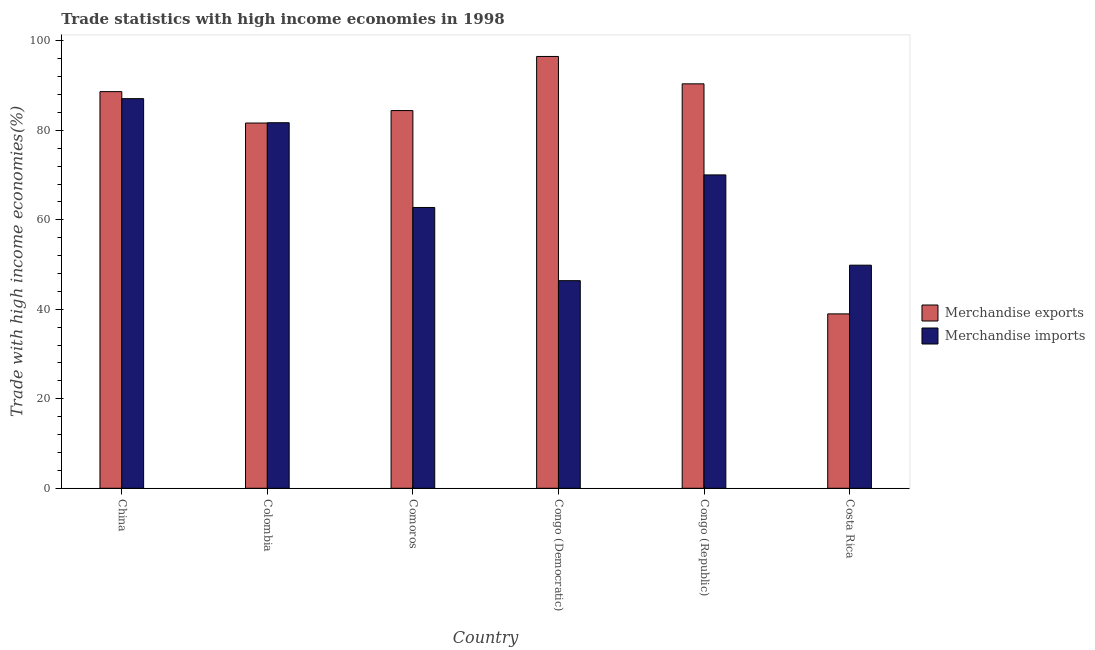How many groups of bars are there?
Ensure brevity in your answer.  6. Are the number of bars per tick equal to the number of legend labels?
Your answer should be compact. Yes. Are the number of bars on each tick of the X-axis equal?
Your response must be concise. Yes. How many bars are there on the 3rd tick from the left?
Your answer should be compact. 2. What is the label of the 5th group of bars from the left?
Give a very brief answer. Congo (Republic). What is the merchandise imports in Comoros?
Your answer should be very brief. 62.76. Across all countries, what is the maximum merchandise imports?
Keep it short and to the point. 87.08. Across all countries, what is the minimum merchandise imports?
Offer a terse response. 46.4. In which country was the merchandise exports minimum?
Offer a very short reply. Costa Rica. What is the total merchandise imports in the graph?
Offer a terse response. 397.84. What is the difference between the merchandise imports in Colombia and that in Congo (Republic)?
Your answer should be very brief. 11.66. What is the difference between the merchandise exports in Congo (Democratic) and the merchandise imports in Colombia?
Provide a succinct answer. 14.81. What is the average merchandise imports per country?
Provide a succinct answer. 66.31. What is the difference between the merchandise exports and merchandise imports in Colombia?
Your response must be concise. -0.07. What is the ratio of the merchandise exports in Colombia to that in Comoros?
Make the answer very short. 0.97. Is the difference between the merchandise imports in Colombia and Congo (Democratic) greater than the difference between the merchandise exports in Colombia and Congo (Democratic)?
Provide a short and direct response. Yes. What is the difference between the highest and the second highest merchandise exports?
Give a very brief answer. 6.12. What is the difference between the highest and the lowest merchandise exports?
Provide a short and direct response. 57.53. Is the sum of the merchandise exports in China and Congo (Democratic) greater than the maximum merchandise imports across all countries?
Provide a succinct answer. Yes. What does the 2nd bar from the right in China represents?
Your response must be concise. Merchandise exports. How many bars are there?
Offer a very short reply. 12. Are all the bars in the graph horizontal?
Provide a succinct answer. No. How many countries are there in the graph?
Provide a short and direct response. 6. What is the difference between two consecutive major ticks on the Y-axis?
Keep it short and to the point. 20. Does the graph contain any zero values?
Offer a terse response. No. Where does the legend appear in the graph?
Provide a succinct answer. Center right. How are the legend labels stacked?
Offer a very short reply. Vertical. What is the title of the graph?
Offer a very short reply. Trade statistics with high income economies in 1998. What is the label or title of the Y-axis?
Your answer should be very brief. Trade with high income economies(%). What is the Trade with high income economies(%) of Merchandise exports in China?
Give a very brief answer. 88.65. What is the Trade with high income economies(%) in Merchandise imports in China?
Give a very brief answer. 87.08. What is the Trade with high income economies(%) in Merchandise exports in Colombia?
Make the answer very short. 81.63. What is the Trade with high income economies(%) of Merchandise imports in Colombia?
Your response must be concise. 81.7. What is the Trade with high income economies(%) of Merchandise exports in Comoros?
Keep it short and to the point. 84.42. What is the Trade with high income economies(%) in Merchandise imports in Comoros?
Make the answer very short. 62.76. What is the Trade with high income economies(%) of Merchandise exports in Congo (Democratic)?
Provide a short and direct response. 96.51. What is the Trade with high income economies(%) in Merchandise imports in Congo (Democratic)?
Offer a very short reply. 46.4. What is the Trade with high income economies(%) in Merchandise exports in Congo (Republic)?
Offer a terse response. 90.39. What is the Trade with high income economies(%) in Merchandise imports in Congo (Republic)?
Your answer should be very brief. 70.04. What is the Trade with high income economies(%) in Merchandise exports in Costa Rica?
Give a very brief answer. 38.98. What is the Trade with high income economies(%) of Merchandise imports in Costa Rica?
Give a very brief answer. 49.86. Across all countries, what is the maximum Trade with high income economies(%) in Merchandise exports?
Your answer should be compact. 96.51. Across all countries, what is the maximum Trade with high income economies(%) in Merchandise imports?
Give a very brief answer. 87.08. Across all countries, what is the minimum Trade with high income economies(%) in Merchandise exports?
Make the answer very short. 38.98. Across all countries, what is the minimum Trade with high income economies(%) in Merchandise imports?
Your answer should be very brief. 46.4. What is the total Trade with high income economies(%) in Merchandise exports in the graph?
Your response must be concise. 480.57. What is the total Trade with high income economies(%) of Merchandise imports in the graph?
Ensure brevity in your answer.  397.84. What is the difference between the Trade with high income economies(%) in Merchandise exports in China and that in Colombia?
Your answer should be compact. 7.02. What is the difference between the Trade with high income economies(%) in Merchandise imports in China and that in Colombia?
Give a very brief answer. 5.38. What is the difference between the Trade with high income economies(%) in Merchandise exports in China and that in Comoros?
Make the answer very short. 4.23. What is the difference between the Trade with high income economies(%) of Merchandise imports in China and that in Comoros?
Your response must be concise. 24.32. What is the difference between the Trade with high income economies(%) of Merchandise exports in China and that in Congo (Democratic)?
Provide a short and direct response. -7.86. What is the difference between the Trade with high income economies(%) in Merchandise imports in China and that in Congo (Democratic)?
Your answer should be very brief. 40.68. What is the difference between the Trade with high income economies(%) in Merchandise exports in China and that in Congo (Republic)?
Provide a short and direct response. -1.74. What is the difference between the Trade with high income economies(%) of Merchandise imports in China and that in Congo (Republic)?
Keep it short and to the point. 17.04. What is the difference between the Trade with high income economies(%) of Merchandise exports in China and that in Costa Rica?
Make the answer very short. 49.67. What is the difference between the Trade with high income economies(%) in Merchandise imports in China and that in Costa Rica?
Your response must be concise. 37.22. What is the difference between the Trade with high income economies(%) of Merchandise exports in Colombia and that in Comoros?
Give a very brief answer. -2.79. What is the difference between the Trade with high income economies(%) of Merchandise imports in Colombia and that in Comoros?
Your answer should be very brief. 18.94. What is the difference between the Trade with high income economies(%) in Merchandise exports in Colombia and that in Congo (Democratic)?
Your response must be concise. -14.88. What is the difference between the Trade with high income economies(%) in Merchandise imports in Colombia and that in Congo (Democratic)?
Provide a succinct answer. 35.3. What is the difference between the Trade with high income economies(%) of Merchandise exports in Colombia and that in Congo (Republic)?
Keep it short and to the point. -8.76. What is the difference between the Trade with high income economies(%) of Merchandise imports in Colombia and that in Congo (Republic)?
Keep it short and to the point. 11.66. What is the difference between the Trade with high income economies(%) in Merchandise exports in Colombia and that in Costa Rica?
Keep it short and to the point. 42.65. What is the difference between the Trade with high income economies(%) in Merchandise imports in Colombia and that in Costa Rica?
Ensure brevity in your answer.  31.84. What is the difference between the Trade with high income economies(%) of Merchandise exports in Comoros and that in Congo (Democratic)?
Provide a short and direct response. -12.09. What is the difference between the Trade with high income economies(%) in Merchandise imports in Comoros and that in Congo (Democratic)?
Your answer should be very brief. 16.36. What is the difference between the Trade with high income economies(%) in Merchandise exports in Comoros and that in Congo (Republic)?
Your answer should be very brief. -5.97. What is the difference between the Trade with high income economies(%) of Merchandise imports in Comoros and that in Congo (Republic)?
Your answer should be very brief. -7.28. What is the difference between the Trade with high income economies(%) of Merchandise exports in Comoros and that in Costa Rica?
Your answer should be compact. 45.44. What is the difference between the Trade with high income economies(%) in Merchandise imports in Comoros and that in Costa Rica?
Offer a terse response. 12.89. What is the difference between the Trade with high income economies(%) in Merchandise exports in Congo (Democratic) and that in Congo (Republic)?
Keep it short and to the point. 6.12. What is the difference between the Trade with high income economies(%) of Merchandise imports in Congo (Democratic) and that in Congo (Republic)?
Keep it short and to the point. -23.64. What is the difference between the Trade with high income economies(%) in Merchandise exports in Congo (Democratic) and that in Costa Rica?
Your response must be concise. 57.53. What is the difference between the Trade with high income economies(%) in Merchandise imports in Congo (Democratic) and that in Costa Rica?
Offer a very short reply. -3.46. What is the difference between the Trade with high income economies(%) in Merchandise exports in Congo (Republic) and that in Costa Rica?
Your answer should be very brief. 51.41. What is the difference between the Trade with high income economies(%) in Merchandise imports in Congo (Republic) and that in Costa Rica?
Provide a short and direct response. 20.17. What is the difference between the Trade with high income economies(%) of Merchandise exports in China and the Trade with high income economies(%) of Merchandise imports in Colombia?
Your answer should be compact. 6.95. What is the difference between the Trade with high income economies(%) of Merchandise exports in China and the Trade with high income economies(%) of Merchandise imports in Comoros?
Make the answer very short. 25.89. What is the difference between the Trade with high income economies(%) of Merchandise exports in China and the Trade with high income economies(%) of Merchandise imports in Congo (Democratic)?
Provide a succinct answer. 42.25. What is the difference between the Trade with high income economies(%) in Merchandise exports in China and the Trade with high income economies(%) in Merchandise imports in Congo (Republic)?
Your response must be concise. 18.61. What is the difference between the Trade with high income economies(%) in Merchandise exports in China and the Trade with high income economies(%) in Merchandise imports in Costa Rica?
Ensure brevity in your answer.  38.79. What is the difference between the Trade with high income economies(%) of Merchandise exports in Colombia and the Trade with high income economies(%) of Merchandise imports in Comoros?
Give a very brief answer. 18.87. What is the difference between the Trade with high income economies(%) of Merchandise exports in Colombia and the Trade with high income economies(%) of Merchandise imports in Congo (Democratic)?
Your response must be concise. 35.23. What is the difference between the Trade with high income economies(%) of Merchandise exports in Colombia and the Trade with high income economies(%) of Merchandise imports in Congo (Republic)?
Give a very brief answer. 11.59. What is the difference between the Trade with high income economies(%) in Merchandise exports in Colombia and the Trade with high income economies(%) in Merchandise imports in Costa Rica?
Provide a short and direct response. 31.77. What is the difference between the Trade with high income economies(%) of Merchandise exports in Comoros and the Trade with high income economies(%) of Merchandise imports in Congo (Democratic)?
Keep it short and to the point. 38.02. What is the difference between the Trade with high income economies(%) in Merchandise exports in Comoros and the Trade with high income economies(%) in Merchandise imports in Congo (Republic)?
Keep it short and to the point. 14.38. What is the difference between the Trade with high income economies(%) of Merchandise exports in Comoros and the Trade with high income economies(%) of Merchandise imports in Costa Rica?
Offer a terse response. 34.55. What is the difference between the Trade with high income economies(%) of Merchandise exports in Congo (Democratic) and the Trade with high income economies(%) of Merchandise imports in Congo (Republic)?
Your answer should be compact. 26.47. What is the difference between the Trade with high income economies(%) in Merchandise exports in Congo (Democratic) and the Trade with high income economies(%) in Merchandise imports in Costa Rica?
Provide a short and direct response. 46.65. What is the difference between the Trade with high income economies(%) in Merchandise exports in Congo (Republic) and the Trade with high income economies(%) in Merchandise imports in Costa Rica?
Offer a terse response. 40.53. What is the average Trade with high income economies(%) in Merchandise exports per country?
Your response must be concise. 80.09. What is the average Trade with high income economies(%) in Merchandise imports per country?
Provide a succinct answer. 66.31. What is the difference between the Trade with high income economies(%) in Merchandise exports and Trade with high income economies(%) in Merchandise imports in China?
Make the answer very short. 1.57. What is the difference between the Trade with high income economies(%) in Merchandise exports and Trade with high income economies(%) in Merchandise imports in Colombia?
Provide a succinct answer. -0.07. What is the difference between the Trade with high income economies(%) of Merchandise exports and Trade with high income economies(%) of Merchandise imports in Comoros?
Provide a short and direct response. 21.66. What is the difference between the Trade with high income economies(%) of Merchandise exports and Trade with high income economies(%) of Merchandise imports in Congo (Democratic)?
Offer a terse response. 50.11. What is the difference between the Trade with high income economies(%) in Merchandise exports and Trade with high income economies(%) in Merchandise imports in Congo (Republic)?
Ensure brevity in your answer.  20.35. What is the difference between the Trade with high income economies(%) in Merchandise exports and Trade with high income economies(%) in Merchandise imports in Costa Rica?
Offer a very short reply. -10.89. What is the ratio of the Trade with high income economies(%) of Merchandise exports in China to that in Colombia?
Your response must be concise. 1.09. What is the ratio of the Trade with high income economies(%) in Merchandise imports in China to that in Colombia?
Make the answer very short. 1.07. What is the ratio of the Trade with high income economies(%) in Merchandise exports in China to that in Comoros?
Your answer should be compact. 1.05. What is the ratio of the Trade with high income economies(%) in Merchandise imports in China to that in Comoros?
Offer a very short reply. 1.39. What is the ratio of the Trade with high income economies(%) of Merchandise exports in China to that in Congo (Democratic)?
Your answer should be compact. 0.92. What is the ratio of the Trade with high income economies(%) in Merchandise imports in China to that in Congo (Democratic)?
Keep it short and to the point. 1.88. What is the ratio of the Trade with high income economies(%) in Merchandise exports in China to that in Congo (Republic)?
Provide a short and direct response. 0.98. What is the ratio of the Trade with high income economies(%) of Merchandise imports in China to that in Congo (Republic)?
Your answer should be compact. 1.24. What is the ratio of the Trade with high income economies(%) of Merchandise exports in China to that in Costa Rica?
Give a very brief answer. 2.27. What is the ratio of the Trade with high income economies(%) of Merchandise imports in China to that in Costa Rica?
Offer a terse response. 1.75. What is the ratio of the Trade with high income economies(%) of Merchandise imports in Colombia to that in Comoros?
Ensure brevity in your answer.  1.3. What is the ratio of the Trade with high income economies(%) of Merchandise exports in Colombia to that in Congo (Democratic)?
Ensure brevity in your answer.  0.85. What is the ratio of the Trade with high income economies(%) in Merchandise imports in Colombia to that in Congo (Democratic)?
Make the answer very short. 1.76. What is the ratio of the Trade with high income economies(%) in Merchandise exports in Colombia to that in Congo (Republic)?
Provide a succinct answer. 0.9. What is the ratio of the Trade with high income economies(%) of Merchandise imports in Colombia to that in Congo (Republic)?
Provide a short and direct response. 1.17. What is the ratio of the Trade with high income economies(%) in Merchandise exports in Colombia to that in Costa Rica?
Make the answer very short. 2.09. What is the ratio of the Trade with high income economies(%) of Merchandise imports in Colombia to that in Costa Rica?
Make the answer very short. 1.64. What is the ratio of the Trade with high income economies(%) of Merchandise exports in Comoros to that in Congo (Democratic)?
Offer a very short reply. 0.87. What is the ratio of the Trade with high income economies(%) of Merchandise imports in Comoros to that in Congo (Democratic)?
Offer a very short reply. 1.35. What is the ratio of the Trade with high income economies(%) of Merchandise exports in Comoros to that in Congo (Republic)?
Your response must be concise. 0.93. What is the ratio of the Trade with high income economies(%) of Merchandise imports in Comoros to that in Congo (Republic)?
Give a very brief answer. 0.9. What is the ratio of the Trade with high income economies(%) of Merchandise exports in Comoros to that in Costa Rica?
Make the answer very short. 2.17. What is the ratio of the Trade with high income economies(%) of Merchandise imports in Comoros to that in Costa Rica?
Ensure brevity in your answer.  1.26. What is the ratio of the Trade with high income economies(%) in Merchandise exports in Congo (Democratic) to that in Congo (Republic)?
Ensure brevity in your answer.  1.07. What is the ratio of the Trade with high income economies(%) of Merchandise imports in Congo (Democratic) to that in Congo (Republic)?
Your answer should be very brief. 0.66. What is the ratio of the Trade with high income economies(%) of Merchandise exports in Congo (Democratic) to that in Costa Rica?
Ensure brevity in your answer.  2.48. What is the ratio of the Trade with high income economies(%) of Merchandise imports in Congo (Democratic) to that in Costa Rica?
Your answer should be compact. 0.93. What is the ratio of the Trade with high income economies(%) in Merchandise exports in Congo (Republic) to that in Costa Rica?
Make the answer very short. 2.32. What is the ratio of the Trade with high income economies(%) of Merchandise imports in Congo (Republic) to that in Costa Rica?
Offer a terse response. 1.4. What is the difference between the highest and the second highest Trade with high income economies(%) of Merchandise exports?
Give a very brief answer. 6.12. What is the difference between the highest and the second highest Trade with high income economies(%) of Merchandise imports?
Make the answer very short. 5.38. What is the difference between the highest and the lowest Trade with high income economies(%) of Merchandise exports?
Give a very brief answer. 57.53. What is the difference between the highest and the lowest Trade with high income economies(%) in Merchandise imports?
Make the answer very short. 40.68. 